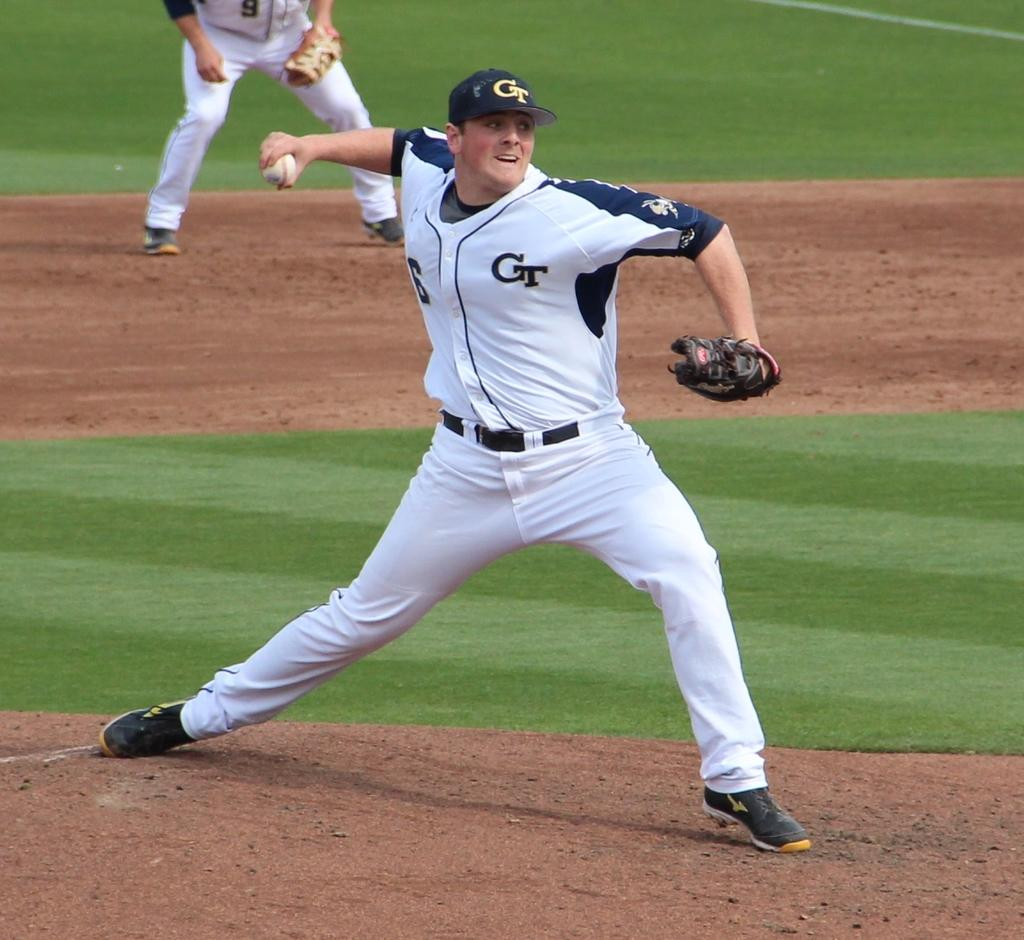<image>
Provide a brief description of the given image. A baseball pitcher is throwing the ball and his uniform says GT. 